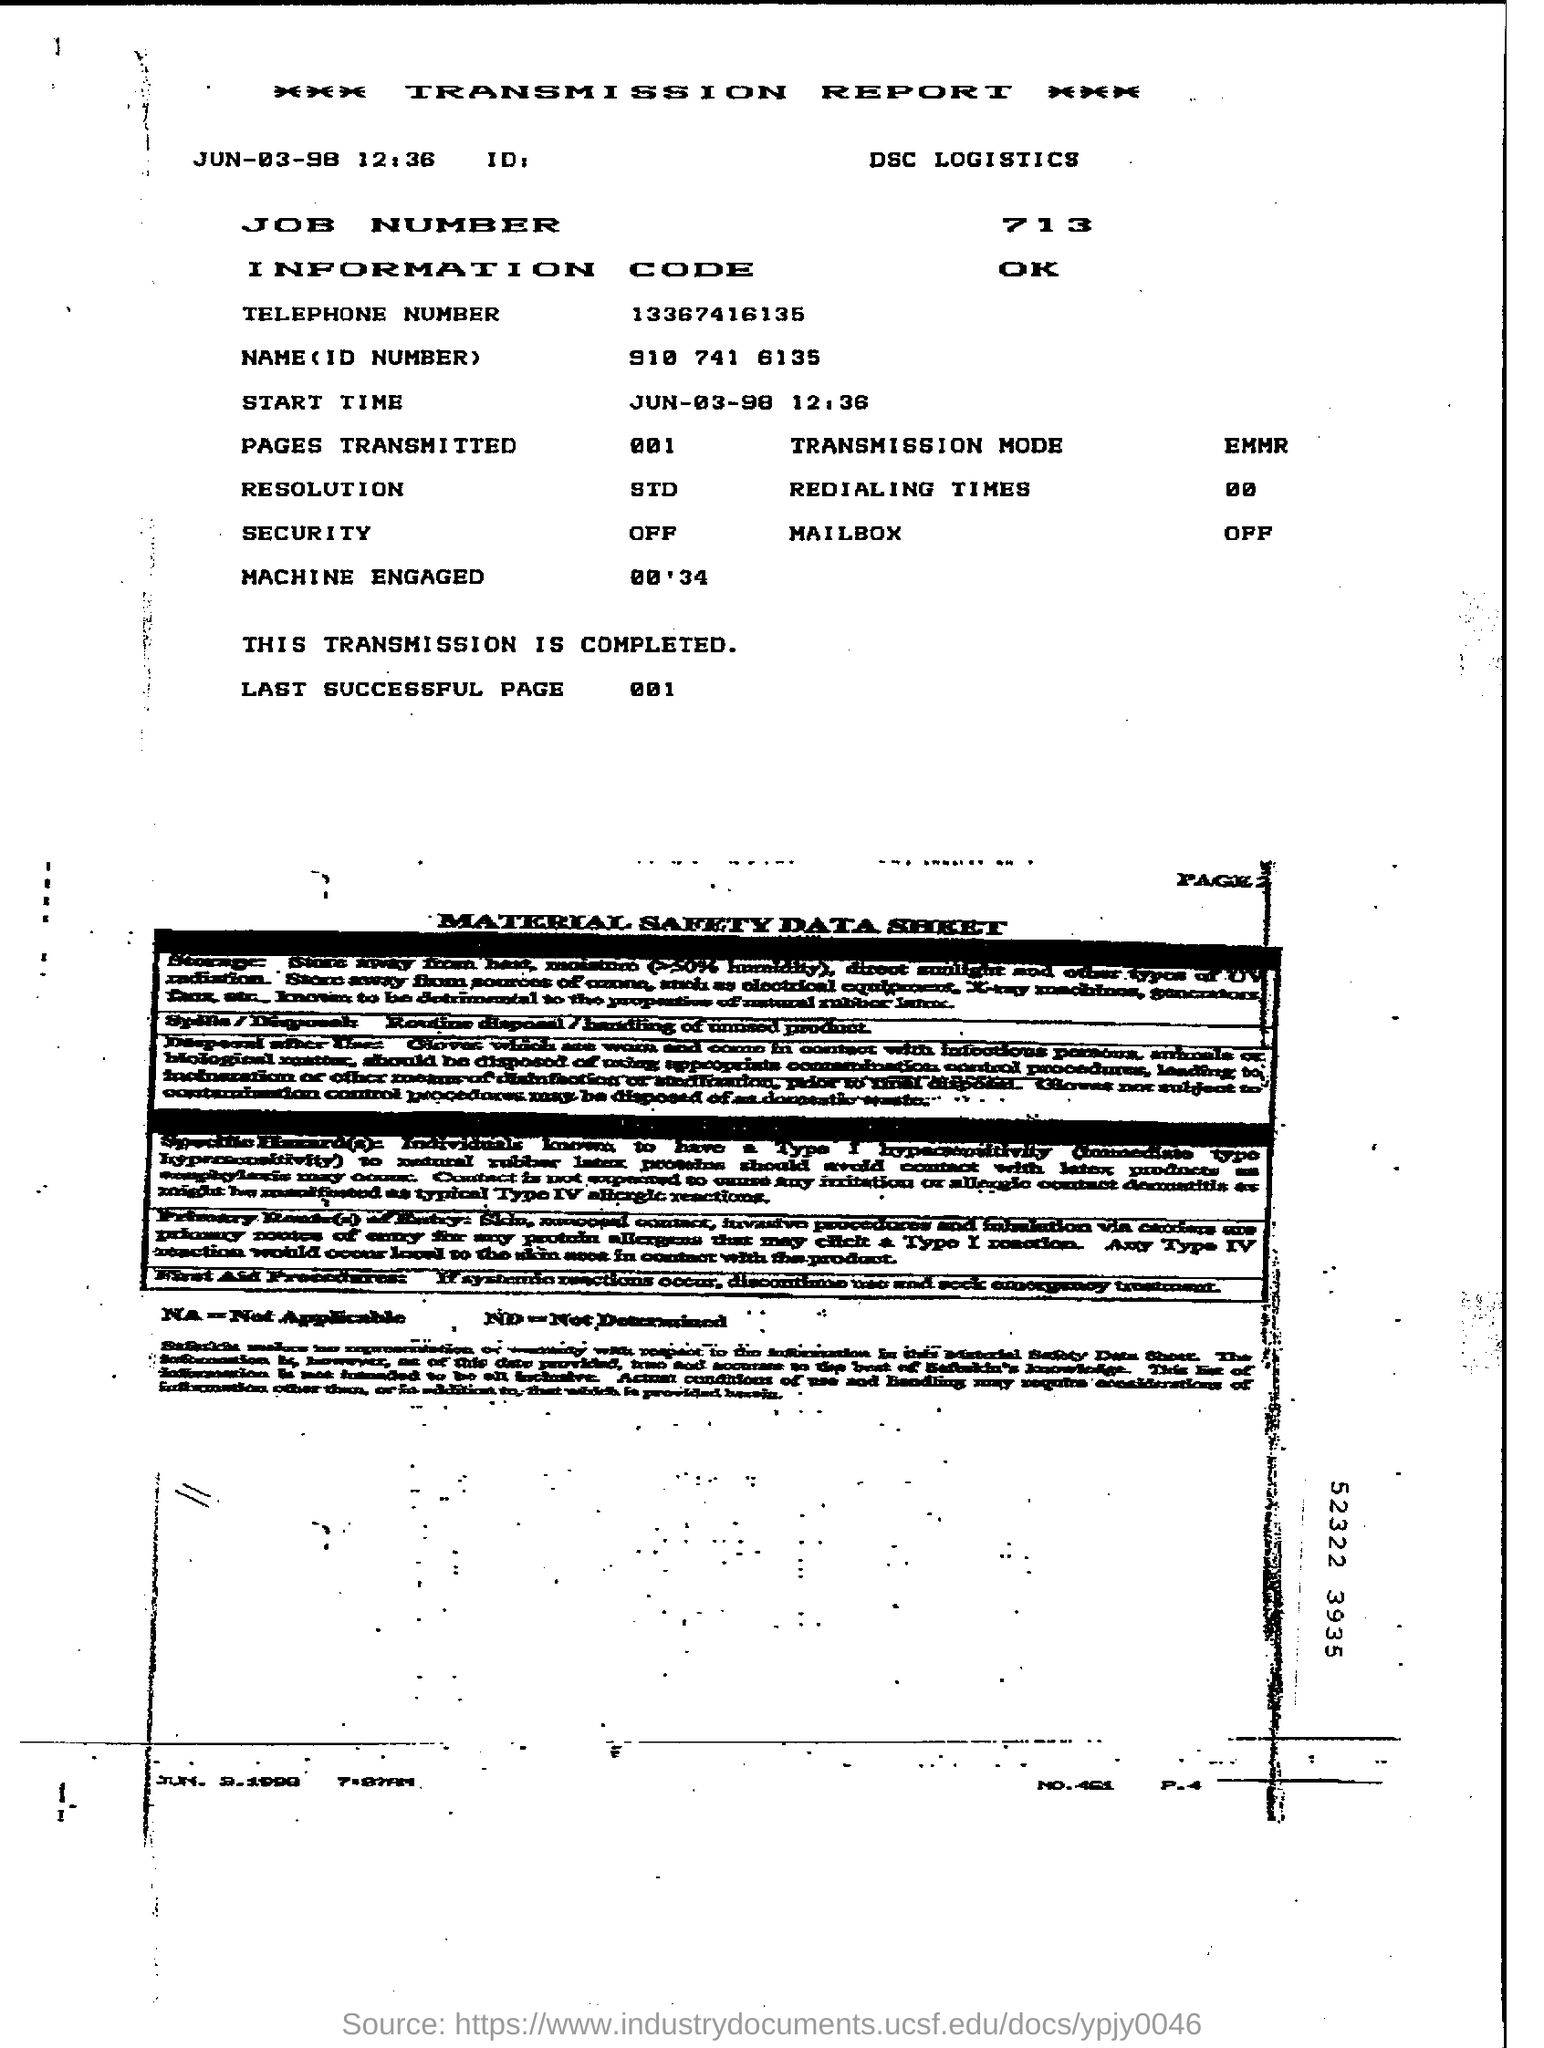What is the name of the logistics ?
Ensure brevity in your answer.  Dsc logistics. What is the job number mentioned in the report ?
Your answer should be very brief. 713. What is the name (id number )given in the report ?
Your answer should be very brief. 910 741 6135. What is the start time given in the report ?
Your response must be concise. JUN-03-98  12:36. What is the status of the security ?
Ensure brevity in your answer.  Off. What i sthe transmission mode mentioned in the report ?
Make the answer very short. EMMR. How many pages are transmitted in the report ?
Make the answer very short. 001. 